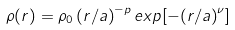Convert formula to latex. <formula><loc_0><loc_0><loc_500><loc_500>\rho ( r ) = \rho _ { 0 } \, { ( r / a ) } ^ { - p } \, e x p [ { - ( r / a ) } ^ { \nu } ]</formula> 